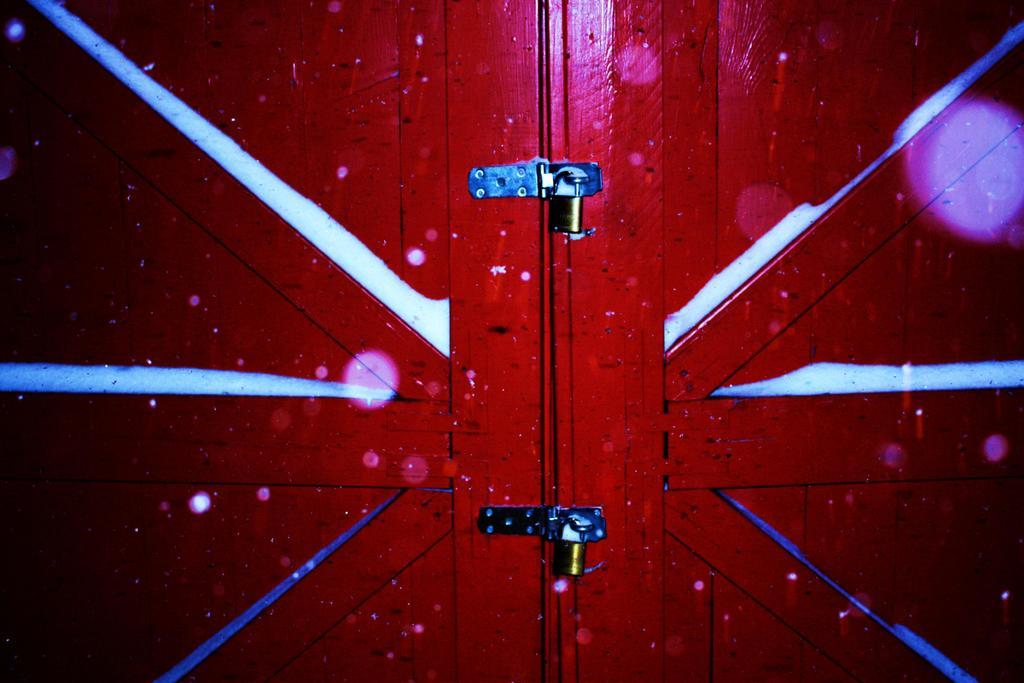What is present in the image that serves as an entrance or exit? There is a door in the image. What colors are used to paint the door? The door is red and white in color. How many locks are present on the door? There are two locks on the door. What type of error can be seen in the image? There is no error present in the image; it features a red and white door with two locks. What kind of clouds are visible in the image? There are no clouds visible in the image, as it only features a door with locks. 